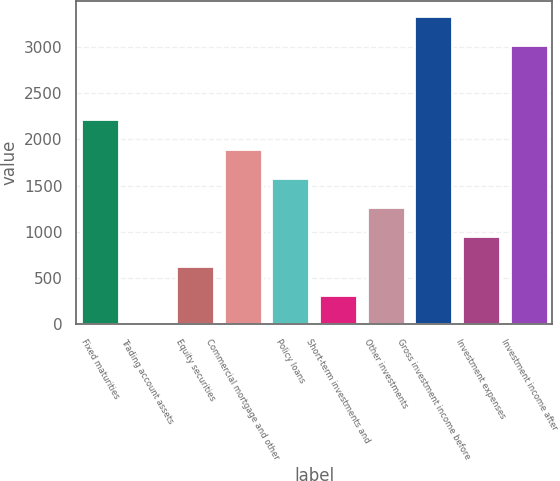Convert chart. <chart><loc_0><loc_0><loc_500><loc_500><bar_chart><fcel>Fixed maturities<fcel>Trading account assets<fcel>Equity securities<fcel>Commercial mortgage and other<fcel>Policy loans<fcel>Short-term investments and<fcel>Other investments<fcel>Gross investment income before<fcel>Investment expenses<fcel>Investment income after<nl><fcel>2216.54<fcel>1.18<fcel>634.14<fcel>1900.06<fcel>1583.58<fcel>317.66<fcel>1267.1<fcel>3332.48<fcel>950.62<fcel>3016<nl></chart> 